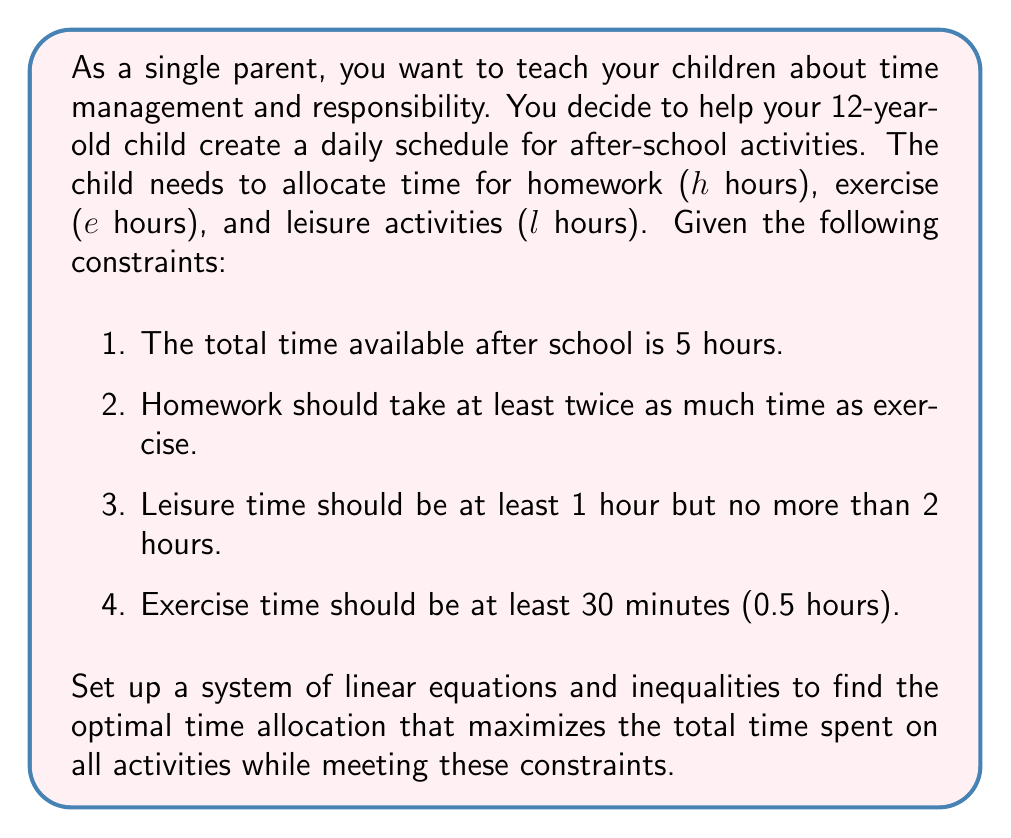Provide a solution to this math problem. Let's approach this problem step by step:

1. Set up the variables:
   $h$ = time spent on homework (in hours)
   $e$ = time spent on exercise (in hours)
   $l$ = time spent on leisure activities (in hours)

2. Write the equations and inequalities based on the given constraints:

   a. Total time constraint:
      $h + e + l = 5$

   b. Homework should take at least twice as much time as exercise:
      $h \geq 2e$

   c. Leisure time constraints:
      $1 \leq l \leq 2$

   d. Exercise time constraint:
      $e \geq 0.5$

3. Our objective is to maximize the total time spent on all activities, which is already constrained to 5 hours. So, we need to find the solution that satisfies all constraints.

4. From the leisure time constraint, we know that $l$ can be at most 2 hours. Let's start with this maximum value:
   $l = 2$

5. Substituting this into the total time constraint:
   $h + e + 2 = 5$
   $h + e = 3$

6. We know that $h \geq 2e$ and $e \geq 0.5$. To maximize both $h$ and $e$ while satisfying these constraints, we can set:
   $e = 1$ and $h = 2$

7. This solution satisfies all constraints:
   - Total time: $2 + 1 + 2 = 5$ hours
   - Homework is twice exercise time: $2 = 2 \times 1$
   - Leisure time is between 1 and 2 hours: $2$ hours
   - Exercise time is at least 30 minutes: $1$ hour > 30 minutes

Therefore, the optimal time allocation is:
Homework (h) = 2 hours
Exercise (e) = 1 hour
Leisure (l) = 2 hours
Answer: The optimal time allocation is:
Homework: 2 hours
Exercise: 1 hour
Leisure: 2 hours 